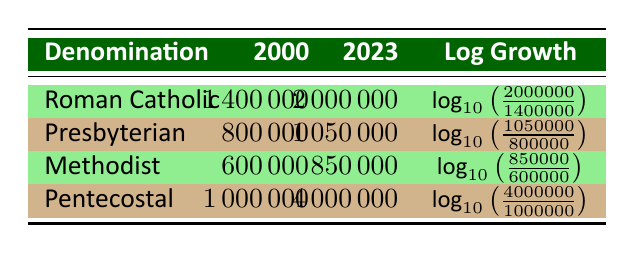What was the membership of the Pentecostal denomination in 2000? The table shows that the membership of the Pentecostal denomination in the year 2000 was listed under that column as 1,000,000.
Answer: 1,000,000 What is the membership of the Roman Catholic denomination in 2023? According to the table, the Roman Catholic denomination's membership in 2023 is recorded as 2,000,000.
Answer: 2,000,000 Which denomination had the highest membership growth from 2000 to 2023? By comparing the log growth values in the table, we see that Pentecostal showed the largest increase, going from 1,000,000 to 4,000,000.
Answer: Pentecostal What is the total membership of the Presbyterian and Methodist denominations in 2023? To find this, we add the memberships of both denominations in 2023: 1,050,000 (Presbyterian) + 850,000 (Methodist) = 1,900,000.
Answer: 1,900,000 Is it true that the membership of the Methodist denomination increased more than the membership of the Presbyterian denomination from 2000 to 2023? The membership growth for Methodist is 850,000 - 600,000 = 250,000, while Presbyterian is 1,050,000 - 800,000 = 250,000; since both are equal, the statement is false.
Answer: No If the total membership of all denominations in 2023 is 4,450,000, what is the total membership for 2000? Adding the memberships from 2000, we have: 1,400,000 (Roman Catholic) + 800,000 (Presbyterian) + 600,000 (Methodist) + 1,000,000 (Pentecostal) = 3,800,000.
Answer: 3,800,000 What is the log growth for the Roman Catholic denomination? The log growth can be calculated using the formula provided: log10(2,000,000/1,400,000), which can be computed to find the log value representing the growth rate. Calculating it gives approximately 0.113.
Answer: Approximately 0.113 Which denominations had a membership of less than 1,000,000 in 2000? Referring to the table, both the Methodist (600,000) and Presbyterian (800,000) denominations had memberships below 1,000,000 in 2000.
Answer: Methodist, Presbyterian Did the Pentecostal denomination have a higher membership increase compared to the Roman Catholic denomination from 2000 to 2023? The increase for Pentecostal is 4,000,000 - 1,000,000 = 3,000,000; for Roman Catholic, it's 2,000,000 - 1,400,000 = 600,000. Thus, Pentecostal had a much larger increase.
Answer: Yes 